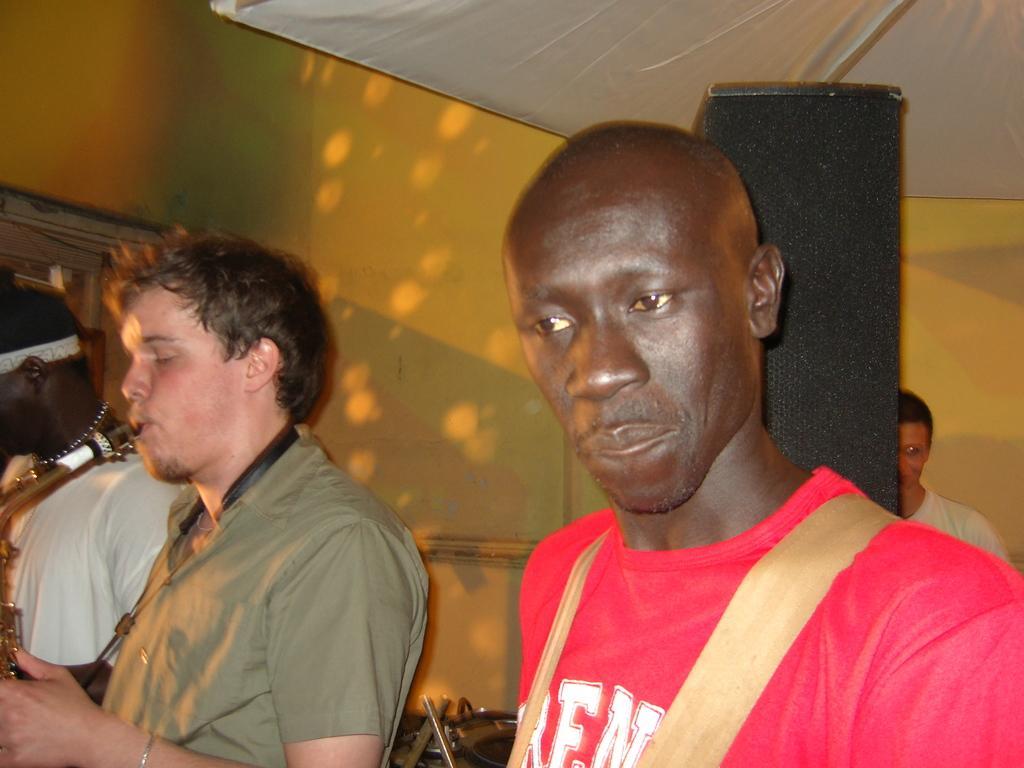How would you summarize this image in a sentence or two? In this picture we can see people and in the background we can see the wall and some objects. 